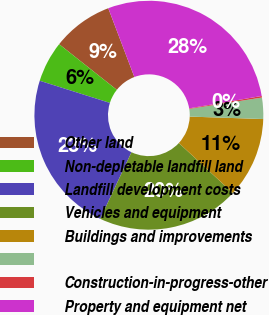Convert chart to OTSL. <chart><loc_0><loc_0><loc_500><loc_500><pie_chart><fcel>Other land<fcel>Non-depletable landfill land<fcel>Landfill development costs<fcel>Vehicles and equipment<fcel>Buildings and improvements<fcel>Unnamed: 5<fcel>Construction-in-progress-other<fcel>Property and equipment net<nl><fcel>8.57%<fcel>5.79%<fcel>22.88%<fcel>20.1%<fcel>11.36%<fcel>3.0%<fcel>0.22%<fcel>28.08%<nl></chart> 